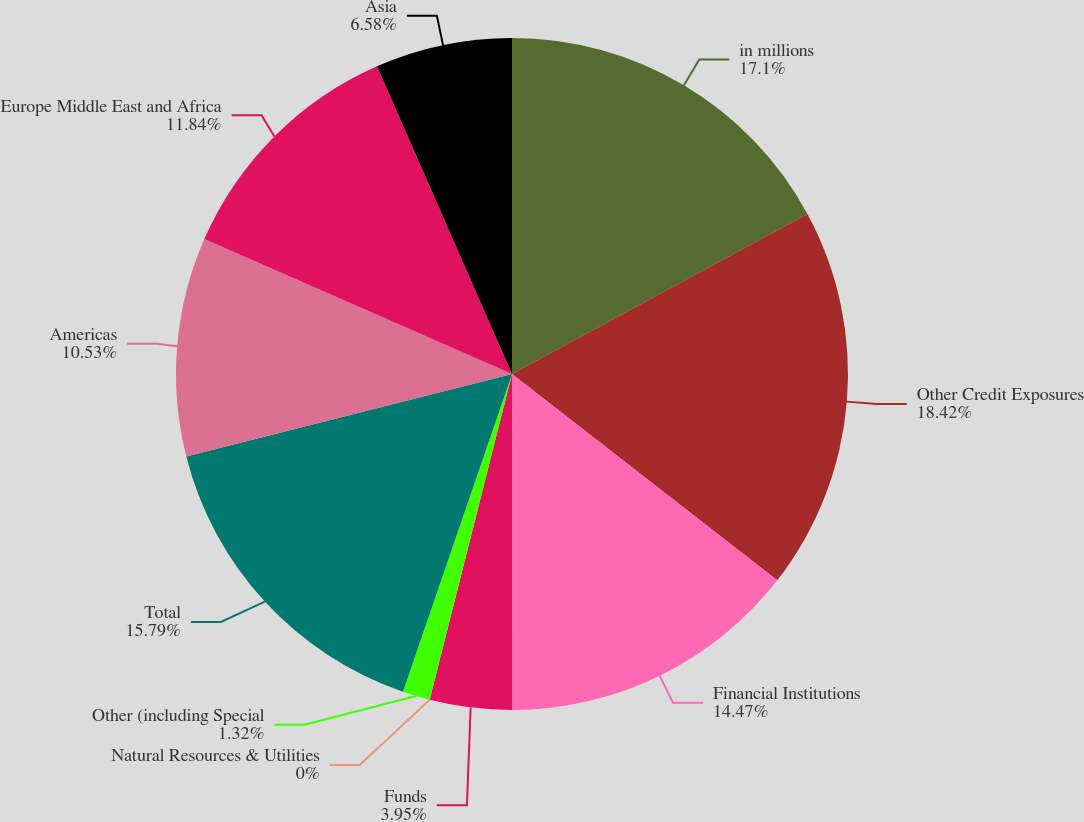Convert chart to OTSL. <chart><loc_0><loc_0><loc_500><loc_500><pie_chart><fcel>in millions<fcel>Other Credit Exposures<fcel>Financial Institutions<fcel>Funds<fcel>Natural Resources & Utilities<fcel>Other (including Special<fcel>Total<fcel>Americas<fcel>Europe Middle East and Africa<fcel>Asia<nl><fcel>17.1%<fcel>18.42%<fcel>14.47%<fcel>3.95%<fcel>0.0%<fcel>1.32%<fcel>15.79%<fcel>10.53%<fcel>11.84%<fcel>6.58%<nl></chart> 